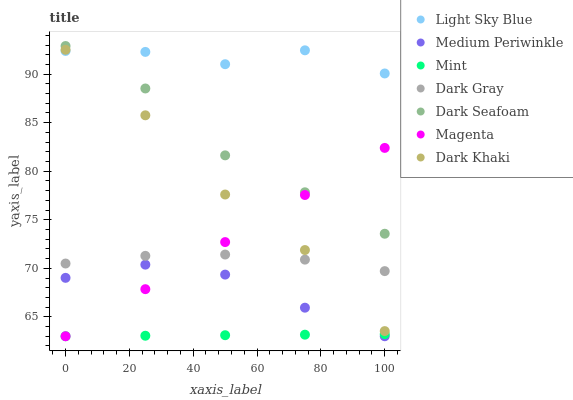Does Mint have the minimum area under the curve?
Answer yes or no. Yes. Does Light Sky Blue have the maximum area under the curve?
Answer yes or no. Yes. Does Medium Periwinkle have the minimum area under the curve?
Answer yes or no. No. Does Medium Periwinkle have the maximum area under the curve?
Answer yes or no. No. Is Mint the smoothest?
Answer yes or no. Yes. Is Light Sky Blue the roughest?
Answer yes or no. Yes. Is Medium Periwinkle the smoothest?
Answer yes or no. No. Is Medium Periwinkle the roughest?
Answer yes or no. No. Does Medium Periwinkle have the lowest value?
Answer yes or no. Yes. Does Dark Gray have the lowest value?
Answer yes or no. No. Does Dark Seafoam have the highest value?
Answer yes or no. Yes. Does Medium Periwinkle have the highest value?
Answer yes or no. No. Is Mint less than Dark Gray?
Answer yes or no. Yes. Is Light Sky Blue greater than Dark Gray?
Answer yes or no. Yes. Does Dark Gray intersect Magenta?
Answer yes or no. Yes. Is Dark Gray less than Magenta?
Answer yes or no. No. Is Dark Gray greater than Magenta?
Answer yes or no. No. Does Mint intersect Dark Gray?
Answer yes or no. No. 